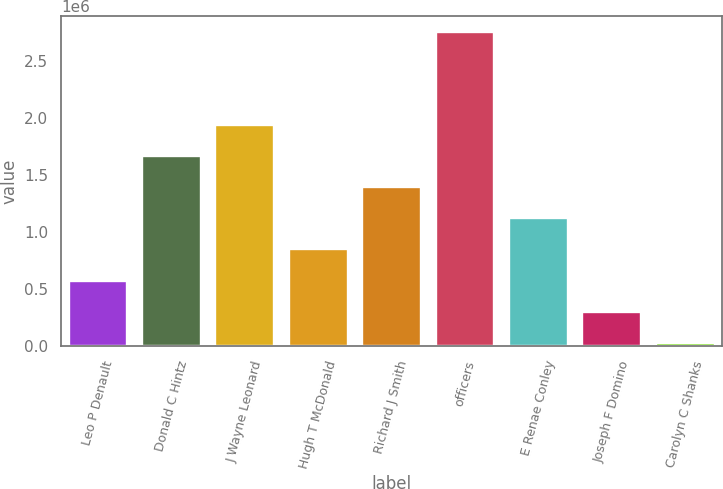<chart> <loc_0><loc_0><loc_500><loc_500><bar_chart><fcel>Leo P Denault<fcel>Donald C Hintz<fcel>J Wayne Leonard<fcel>Hugh T McDonald<fcel>Richard J Smith<fcel>officers<fcel>E Renae Conley<fcel>Joseph F Domino<fcel>Carolyn C Shanks<nl><fcel>575374<fcel>1.66746e+06<fcel>1.94048e+06<fcel>848395<fcel>1.39444e+06<fcel>2.75954e+06<fcel>1.12142e+06<fcel>302354<fcel>29333<nl></chart> 